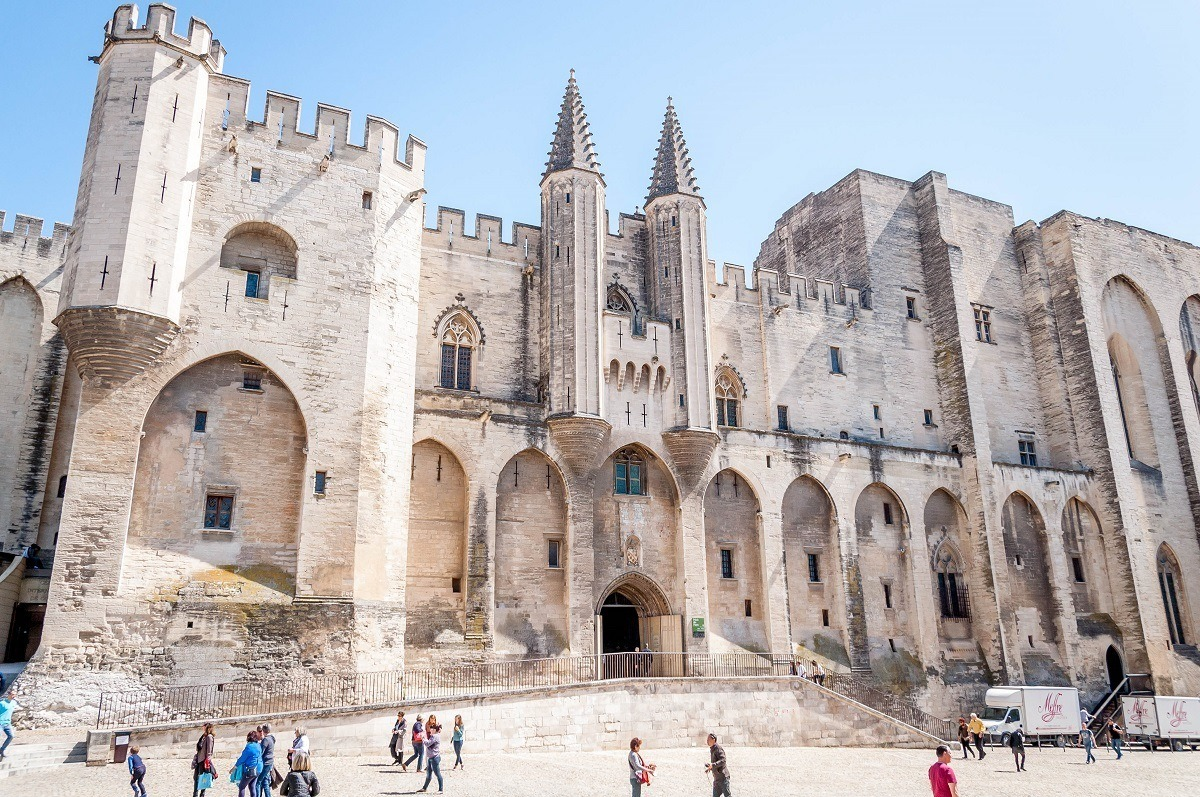From a historical perspective, how did the construction of the Papal Palace influence the local architecture of Avignon? The construction of the Papal Palace had a profound impact on the architectural landscape of Avignon. It set a precedent for grandiose and monumental architecture in the region, influencing the design of subsequent buildings both in scale and style. The use of Gothic elements such as pointed arches, ribbed vaults, and flying buttresses became more prevalent, as local builders and architects sought to emulate the impressive structure. The stonework techniques and craftsmanship showcased in the palace found echoes in the construction of churches, civic buildings, and even residential structures. The focus on fortification and aesthetic grandeur inspired a wave of construction that combined defensive practicality with ornate artistry, making Avignon a city renowned for its architectural heritage. 